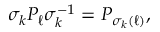Convert formula to latex. <formula><loc_0><loc_0><loc_500><loc_500>\sigma _ { k } P _ { \ell } \sigma _ { k } ^ { - 1 } = P _ { \sigma _ { k } ( \ell ) } ,</formula> 